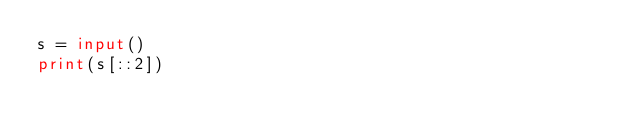Convert code to text. <code><loc_0><loc_0><loc_500><loc_500><_Python_>s = input()
print(s[::2])
</code> 